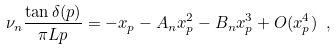<formula> <loc_0><loc_0><loc_500><loc_500>\nu _ { n } \frac { \tan \delta ( p ) } { \pi L p } = - x _ { p } - A _ { n } x _ { p } ^ { 2 } - B _ { n } x _ { p } ^ { 3 } + O ( x _ { p } ^ { 4 } ) \ ,</formula> 